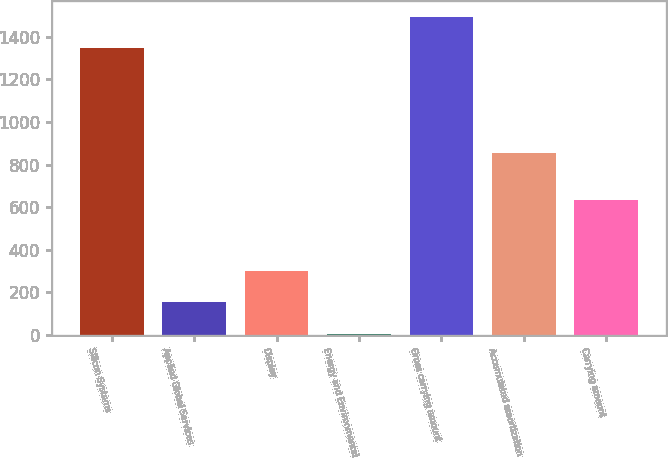Convert chart to OTSL. <chart><loc_0><loc_0><loc_500><loc_500><bar_chart><fcel>Silicon Systems<fcel>Applied Global Services<fcel>Display<fcel>Energy and Environmental<fcel>Gross carrying amount<fcel>Accumulated amortization<fcel>Carrying amount<nl><fcel>1346<fcel>153.4<fcel>301.8<fcel>5<fcel>1494.4<fcel>853<fcel>636<nl></chart> 